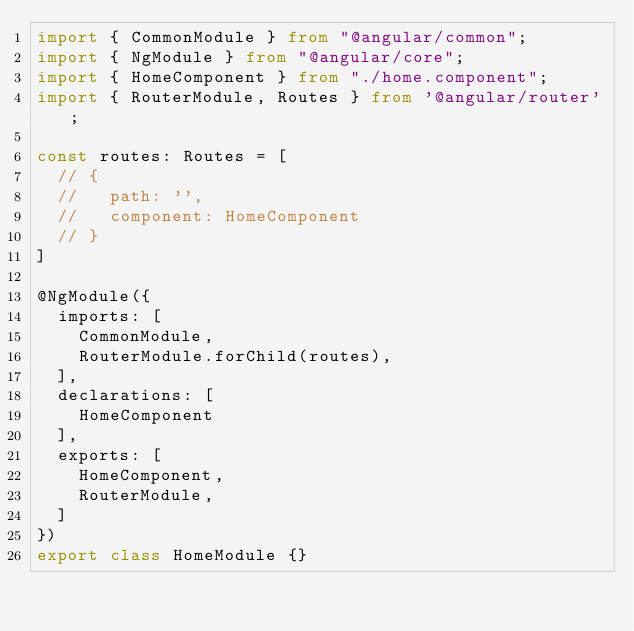Convert code to text. <code><loc_0><loc_0><loc_500><loc_500><_TypeScript_>import { CommonModule } from "@angular/common";
import { NgModule } from "@angular/core";
import { HomeComponent } from "./home.component";
import { RouterModule, Routes } from '@angular/router';

const routes: Routes = [
  // {
  //   path: '',
  //   component: HomeComponent
  // }
]

@NgModule({
  imports: [
    CommonModule,
    RouterModule.forChild(routes),
  ],
  declarations: [
    HomeComponent
  ],
  exports: [
    HomeComponent,
    RouterModule,
  ]
})
export class HomeModule {}
</code> 